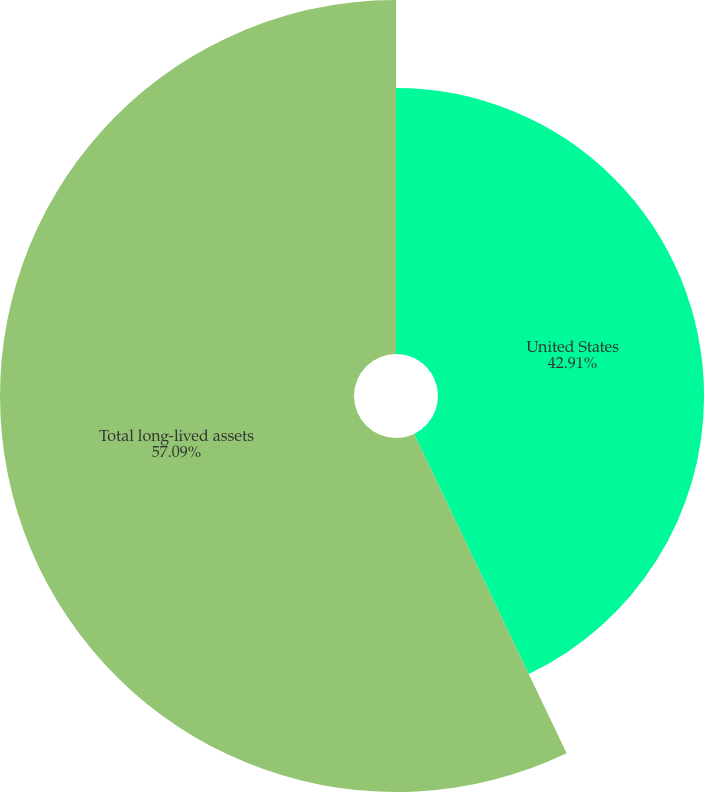<chart> <loc_0><loc_0><loc_500><loc_500><pie_chart><fcel>United States<fcel>Total long-lived assets<nl><fcel>42.91%<fcel>57.09%<nl></chart> 